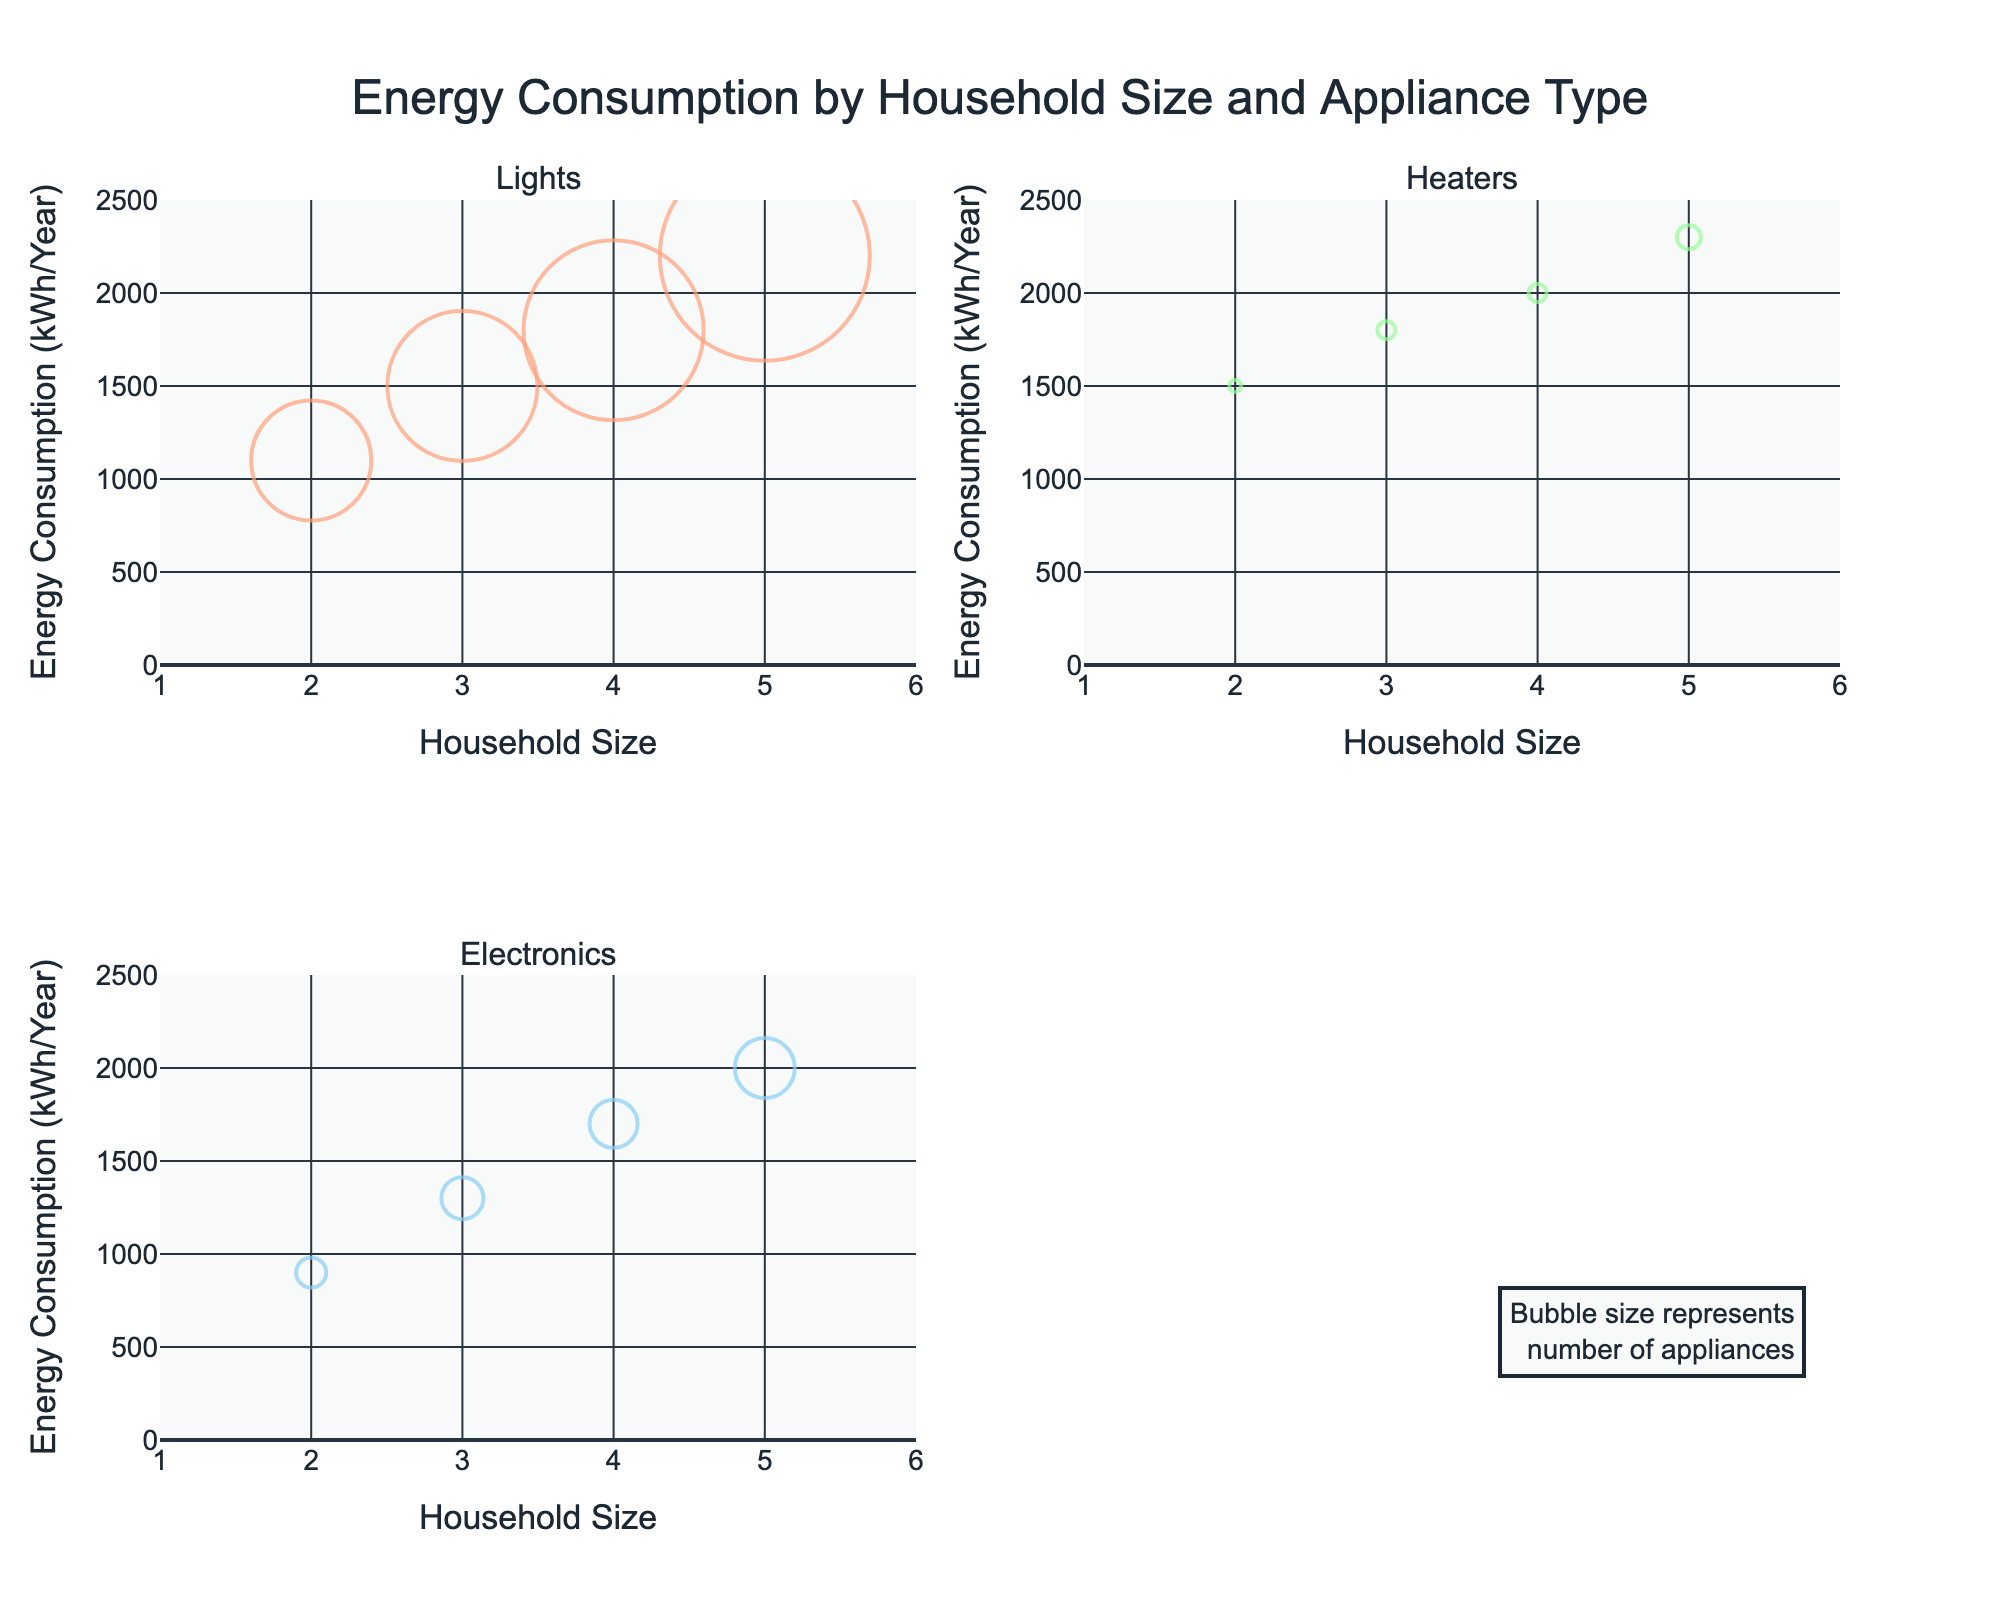How many subplots are there in the figure? The figure consists of four subplots, three of which are dedicated to different appliance types: Lights, Heaters, and Electronics, with one remaining empty.
Answer: Four What does the bubble size in the figure represent? The bubble size represents the number of appliances. This is indicated by the annotation that states, "Bubble size represents number of appliances."
Answer: Number of appliances Which appliance type shows the highest energy consumption for a household size of 5? For household size of 5, the Heaters have the highest energy consumption, as indicated by the highest point in the plot for Heaters.
Answer: Heaters How does energy consumption for Lights change as household size increases from 2 to 5? As the household size increases, energy consumption for Lights also increases. The data points show a trend where energy consumption goes from 1100 kWh/year for size 2 to 2200 kWh/year for size 5.
Answer: Increases Which household size has the most appliances for Electronics, and how many are there? The household size of 5 has the highest number of Electronics appliances, with a total of 10 appliances. This can be seen by the largest bubble in the Electronics subplot corresponding to household size 5.
Answer: 5, 10 appliances Compare the energy consumption for Heaters for household sizes of 3 and 4. Which one is higher and by how much? For household size 3, energy consumption is 1800 kWh/year, and for size 4, it’s 2000 kWh/year. The difference is 2000 - 1800 = 200 kWh/year.
Answer: 4, 200 kWh/year What is the average energy consumption for Electronics appliances across all household sizes? The energy consumption values for Electronics are 900, 1300, 1700, 2000 kWh/year for household sizes 2, 3, 4, and 5 respectively. The average is (900 + 1300 + 1700 + 2000) / 4 = 1475 kWh/year.
Answer: 1475 kWh/year Compare the change in the number of Lights appliances as household size increases from 2 to 3 and from 4 to 5. Which change is larger? From household size 2 to 3, the number of Lights appliances increases from 20 to 25 (a change of 5). From household size 4 to 5, it changes from 30 to 35 (also a change of 5). Therefore, both changes are equal.
Answer: Both are equal For which household size are the bubbles largest for Electronics, and how does this relate to energy consumption? The largest bubbles for Electronics are for household size 5, indicating the most number of appliances (10). This also corresponds to the highest energy consumption for Electronics at 2000 kWh/year.
Answer: Size 5, 2000 kWh/year 